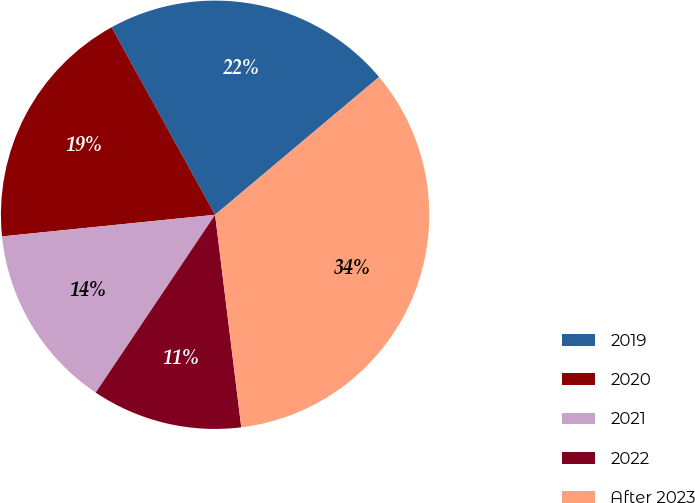Convert chart. <chart><loc_0><loc_0><loc_500><loc_500><pie_chart><fcel>2019<fcel>2020<fcel>2021<fcel>2022<fcel>After 2023<nl><fcel>21.91%<fcel>18.58%<fcel>13.98%<fcel>11.36%<fcel>34.17%<nl></chart> 